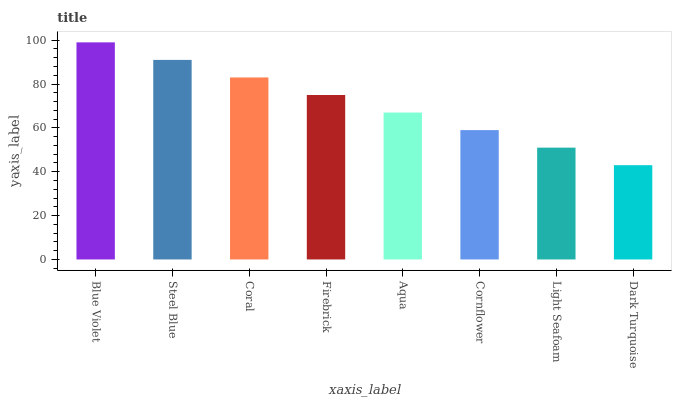Is Steel Blue the minimum?
Answer yes or no. No. Is Steel Blue the maximum?
Answer yes or no. No. Is Blue Violet greater than Steel Blue?
Answer yes or no. Yes. Is Steel Blue less than Blue Violet?
Answer yes or no. Yes. Is Steel Blue greater than Blue Violet?
Answer yes or no. No. Is Blue Violet less than Steel Blue?
Answer yes or no. No. Is Firebrick the high median?
Answer yes or no. Yes. Is Aqua the low median?
Answer yes or no. Yes. Is Cornflower the high median?
Answer yes or no. No. Is Cornflower the low median?
Answer yes or no. No. 